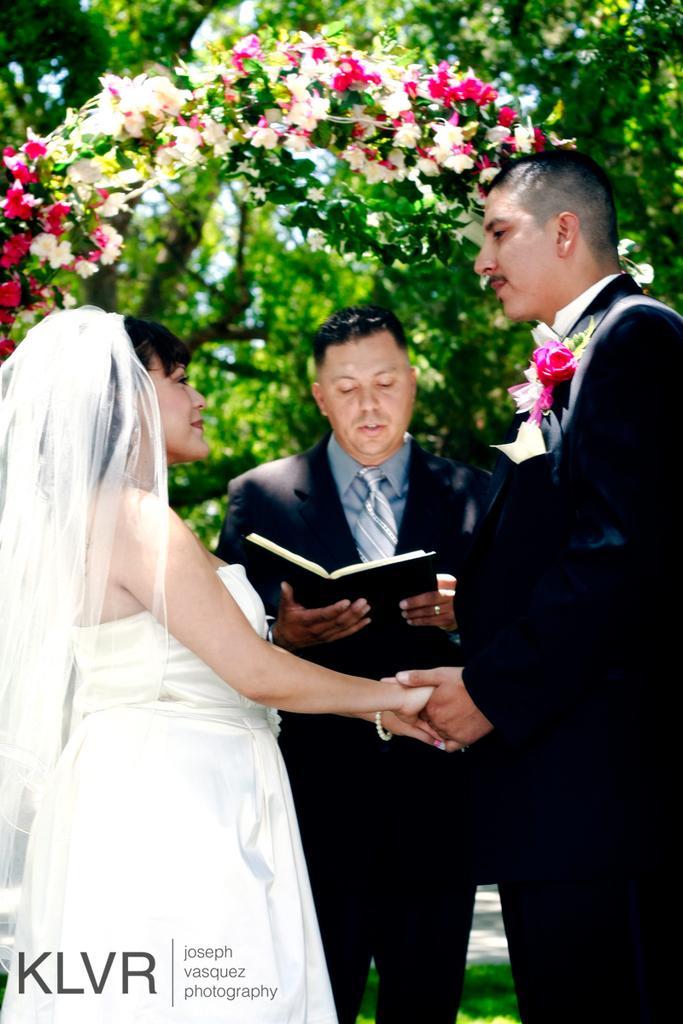Can you describe this image briefly? In the foreground of this image, there is a man and a woman holding hands. Behind them, there is a man holding a book. In the background, there are trees and at the top, there is an arch with flowers. 